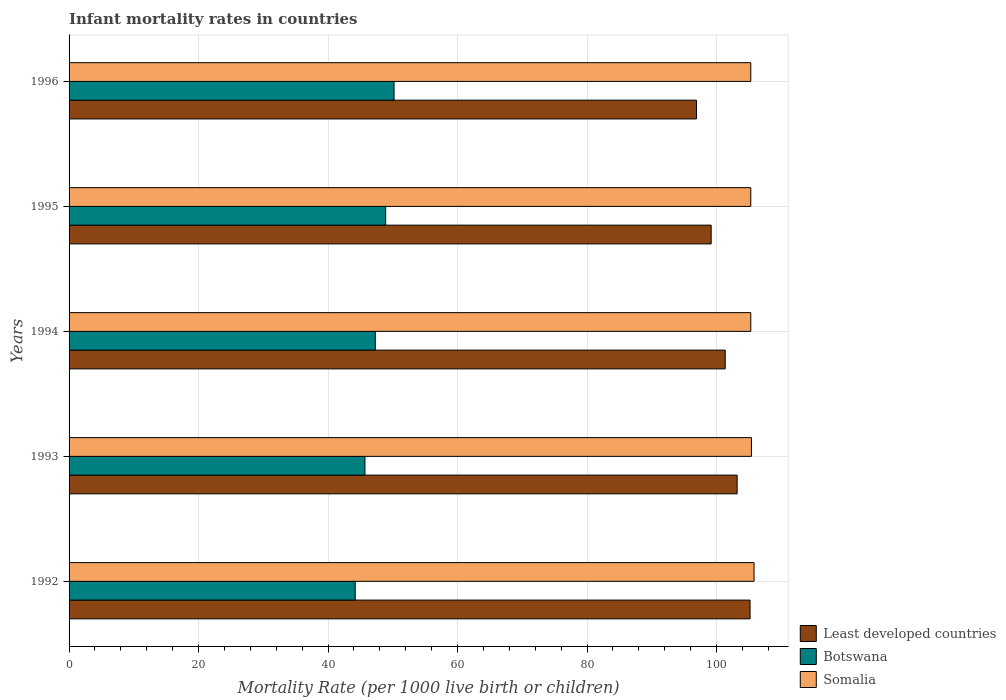How many groups of bars are there?
Provide a succinct answer. 5. Are the number of bars on each tick of the Y-axis equal?
Ensure brevity in your answer.  Yes. How many bars are there on the 5th tick from the top?
Your answer should be compact. 3. How many bars are there on the 3rd tick from the bottom?
Your answer should be very brief. 3. What is the label of the 4th group of bars from the top?
Keep it short and to the point. 1993. In how many cases, is the number of bars for a given year not equal to the number of legend labels?
Provide a short and direct response. 0. What is the infant mortality rate in Botswana in 1994?
Your answer should be very brief. 47.3. Across all years, what is the maximum infant mortality rate in Least developed countries?
Keep it short and to the point. 105.19. Across all years, what is the minimum infant mortality rate in Least developed countries?
Your answer should be very brief. 96.91. What is the total infant mortality rate in Somalia in the graph?
Offer a terse response. 527.1. What is the difference between the infant mortality rate in Least developed countries in 1993 and that in 1994?
Your answer should be very brief. 1.84. What is the difference between the infant mortality rate in Somalia in 1992 and the infant mortality rate in Botswana in 1995?
Your answer should be compact. 56.9. What is the average infant mortality rate in Botswana per year?
Provide a succinct answer. 47.26. In the year 1994, what is the difference between the infant mortality rate in Least developed countries and infant mortality rate in Botswana?
Keep it short and to the point. 54.05. What is the ratio of the infant mortality rate in Botswana in 1992 to that in 1996?
Your answer should be compact. 0.88. What is the difference between the highest and the second highest infant mortality rate in Least developed countries?
Your response must be concise. 1.99. In how many years, is the infant mortality rate in Somalia greater than the average infant mortality rate in Somalia taken over all years?
Your answer should be very brief. 1. What does the 1st bar from the top in 1994 represents?
Make the answer very short. Somalia. What does the 3rd bar from the bottom in 1996 represents?
Make the answer very short. Somalia. Is it the case that in every year, the sum of the infant mortality rate in Botswana and infant mortality rate in Least developed countries is greater than the infant mortality rate in Somalia?
Your answer should be compact. Yes. How many bars are there?
Give a very brief answer. 15. How many years are there in the graph?
Offer a terse response. 5. Are the values on the major ticks of X-axis written in scientific E-notation?
Your response must be concise. No. Does the graph contain grids?
Your answer should be compact. Yes. Where does the legend appear in the graph?
Offer a terse response. Bottom right. What is the title of the graph?
Give a very brief answer. Infant mortality rates in countries. Does "Palau" appear as one of the legend labels in the graph?
Offer a very short reply. No. What is the label or title of the X-axis?
Offer a very short reply. Mortality Rate (per 1000 live birth or children). What is the label or title of the Y-axis?
Offer a terse response. Years. What is the Mortality Rate (per 1000 live birth or children) of Least developed countries in 1992?
Make the answer very short. 105.19. What is the Mortality Rate (per 1000 live birth or children) in Botswana in 1992?
Provide a short and direct response. 44.2. What is the Mortality Rate (per 1000 live birth or children) in Somalia in 1992?
Provide a short and direct response. 105.8. What is the Mortality Rate (per 1000 live birth or children) of Least developed countries in 1993?
Provide a short and direct response. 103.19. What is the Mortality Rate (per 1000 live birth or children) in Botswana in 1993?
Provide a short and direct response. 45.7. What is the Mortality Rate (per 1000 live birth or children) in Somalia in 1993?
Provide a short and direct response. 105.4. What is the Mortality Rate (per 1000 live birth or children) of Least developed countries in 1994?
Your response must be concise. 101.35. What is the Mortality Rate (per 1000 live birth or children) of Botswana in 1994?
Provide a short and direct response. 47.3. What is the Mortality Rate (per 1000 live birth or children) in Somalia in 1994?
Your answer should be very brief. 105.3. What is the Mortality Rate (per 1000 live birth or children) of Least developed countries in 1995?
Provide a succinct answer. 99.18. What is the Mortality Rate (per 1000 live birth or children) in Botswana in 1995?
Offer a terse response. 48.9. What is the Mortality Rate (per 1000 live birth or children) in Somalia in 1995?
Make the answer very short. 105.3. What is the Mortality Rate (per 1000 live birth or children) of Least developed countries in 1996?
Offer a very short reply. 96.91. What is the Mortality Rate (per 1000 live birth or children) in Botswana in 1996?
Make the answer very short. 50.2. What is the Mortality Rate (per 1000 live birth or children) of Somalia in 1996?
Your answer should be very brief. 105.3. Across all years, what is the maximum Mortality Rate (per 1000 live birth or children) of Least developed countries?
Keep it short and to the point. 105.19. Across all years, what is the maximum Mortality Rate (per 1000 live birth or children) in Botswana?
Make the answer very short. 50.2. Across all years, what is the maximum Mortality Rate (per 1000 live birth or children) of Somalia?
Provide a short and direct response. 105.8. Across all years, what is the minimum Mortality Rate (per 1000 live birth or children) in Least developed countries?
Provide a succinct answer. 96.91. Across all years, what is the minimum Mortality Rate (per 1000 live birth or children) of Botswana?
Your answer should be compact. 44.2. Across all years, what is the minimum Mortality Rate (per 1000 live birth or children) in Somalia?
Provide a succinct answer. 105.3. What is the total Mortality Rate (per 1000 live birth or children) of Least developed countries in the graph?
Your answer should be compact. 505.82. What is the total Mortality Rate (per 1000 live birth or children) in Botswana in the graph?
Offer a terse response. 236.3. What is the total Mortality Rate (per 1000 live birth or children) in Somalia in the graph?
Keep it short and to the point. 527.1. What is the difference between the Mortality Rate (per 1000 live birth or children) of Least developed countries in 1992 and that in 1993?
Give a very brief answer. 1.99. What is the difference between the Mortality Rate (per 1000 live birth or children) of Botswana in 1992 and that in 1993?
Your answer should be compact. -1.5. What is the difference between the Mortality Rate (per 1000 live birth or children) of Least developed countries in 1992 and that in 1994?
Keep it short and to the point. 3.84. What is the difference between the Mortality Rate (per 1000 live birth or children) of Botswana in 1992 and that in 1994?
Provide a succinct answer. -3.1. What is the difference between the Mortality Rate (per 1000 live birth or children) in Least developed countries in 1992 and that in 1995?
Your answer should be very brief. 6.01. What is the difference between the Mortality Rate (per 1000 live birth or children) of Somalia in 1992 and that in 1995?
Your answer should be compact. 0.5. What is the difference between the Mortality Rate (per 1000 live birth or children) in Least developed countries in 1992 and that in 1996?
Offer a very short reply. 8.27. What is the difference between the Mortality Rate (per 1000 live birth or children) in Botswana in 1992 and that in 1996?
Give a very brief answer. -6. What is the difference between the Mortality Rate (per 1000 live birth or children) in Somalia in 1992 and that in 1996?
Offer a terse response. 0.5. What is the difference between the Mortality Rate (per 1000 live birth or children) of Least developed countries in 1993 and that in 1994?
Offer a very short reply. 1.84. What is the difference between the Mortality Rate (per 1000 live birth or children) of Botswana in 1993 and that in 1994?
Your response must be concise. -1.6. What is the difference between the Mortality Rate (per 1000 live birth or children) in Least developed countries in 1993 and that in 1995?
Your response must be concise. 4.01. What is the difference between the Mortality Rate (per 1000 live birth or children) in Least developed countries in 1993 and that in 1996?
Offer a terse response. 6.28. What is the difference between the Mortality Rate (per 1000 live birth or children) in Somalia in 1993 and that in 1996?
Offer a very short reply. 0.1. What is the difference between the Mortality Rate (per 1000 live birth or children) in Least developed countries in 1994 and that in 1995?
Your answer should be compact. 2.17. What is the difference between the Mortality Rate (per 1000 live birth or children) of Botswana in 1994 and that in 1995?
Ensure brevity in your answer.  -1.6. What is the difference between the Mortality Rate (per 1000 live birth or children) of Least developed countries in 1994 and that in 1996?
Give a very brief answer. 4.44. What is the difference between the Mortality Rate (per 1000 live birth or children) of Botswana in 1994 and that in 1996?
Give a very brief answer. -2.9. What is the difference between the Mortality Rate (per 1000 live birth or children) in Somalia in 1994 and that in 1996?
Offer a terse response. 0. What is the difference between the Mortality Rate (per 1000 live birth or children) in Least developed countries in 1995 and that in 1996?
Keep it short and to the point. 2.27. What is the difference between the Mortality Rate (per 1000 live birth or children) of Somalia in 1995 and that in 1996?
Your answer should be very brief. 0. What is the difference between the Mortality Rate (per 1000 live birth or children) of Least developed countries in 1992 and the Mortality Rate (per 1000 live birth or children) of Botswana in 1993?
Offer a very short reply. 59.49. What is the difference between the Mortality Rate (per 1000 live birth or children) of Least developed countries in 1992 and the Mortality Rate (per 1000 live birth or children) of Somalia in 1993?
Your answer should be very brief. -0.21. What is the difference between the Mortality Rate (per 1000 live birth or children) in Botswana in 1992 and the Mortality Rate (per 1000 live birth or children) in Somalia in 1993?
Provide a succinct answer. -61.2. What is the difference between the Mortality Rate (per 1000 live birth or children) of Least developed countries in 1992 and the Mortality Rate (per 1000 live birth or children) of Botswana in 1994?
Provide a succinct answer. 57.89. What is the difference between the Mortality Rate (per 1000 live birth or children) of Least developed countries in 1992 and the Mortality Rate (per 1000 live birth or children) of Somalia in 1994?
Offer a very short reply. -0.11. What is the difference between the Mortality Rate (per 1000 live birth or children) in Botswana in 1992 and the Mortality Rate (per 1000 live birth or children) in Somalia in 1994?
Your answer should be compact. -61.1. What is the difference between the Mortality Rate (per 1000 live birth or children) of Least developed countries in 1992 and the Mortality Rate (per 1000 live birth or children) of Botswana in 1995?
Make the answer very short. 56.29. What is the difference between the Mortality Rate (per 1000 live birth or children) in Least developed countries in 1992 and the Mortality Rate (per 1000 live birth or children) in Somalia in 1995?
Your response must be concise. -0.11. What is the difference between the Mortality Rate (per 1000 live birth or children) of Botswana in 1992 and the Mortality Rate (per 1000 live birth or children) of Somalia in 1995?
Provide a short and direct response. -61.1. What is the difference between the Mortality Rate (per 1000 live birth or children) in Least developed countries in 1992 and the Mortality Rate (per 1000 live birth or children) in Botswana in 1996?
Offer a terse response. 54.99. What is the difference between the Mortality Rate (per 1000 live birth or children) of Least developed countries in 1992 and the Mortality Rate (per 1000 live birth or children) of Somalia in 1996?
Give a very brief answer. -0.11. What is the difference between the Mortality Rate (per 1000 live birth or children) in Botswana in 1992 and the Mortality Rate (per 1000 live birth or children) in Somalia in 1996?
Offer a terse response. -61.1. What is the difference between the Mortality Rate (per 1000 live birth or children) of Least developed countries in 1993 and the Mortality Rate (per 1000 live birth or children) of Botswana in 1994?
Provide a succinct answer. 55.89. What is the difference between the Mortality Rate (per 1000 live birth or children) in Least developed countries in 1993 and the Mortality Rate (per 1000 live birth or children) in Somalia in 1994?
Your answer should be very brief. -2.11. What is the difference between the Mortality Rate (per 1000 live birth or children) in Botswana in 1993 and the Mortality Rate (per 1000 live birth or children) in Somalia in 1994?
Your answer should be compact. -59.6. What is the difference between the Mortality Rate (per 1000 live birth or children) in Least developed countries in 1993 and the Mortality Rate (per 1000 live birth or children) in Botswana in 1995?
Make the answer very short. 54.29. What is the difference between the Mortality Rate (per 1000 live birth or children) of Least developed countries in 1993 and the Mortality Rate (per 1000 live birth or children) of Somalia in 1995?
Give a very brief answer. -2.11. What is the difference between the Mortality Rate (per 1000 live birth or children) in Botswana in 1993 and the Mortality Rate (per 1000 live birth or children) in Somalia in 1995?
Your response must be concise. -59.6. What is the difference between the Mortality Rate (per 1000 live birth or children) in Least developed countries in 1993 and the Mortality Rate (per 1000 live birth or children) in Botswana in 1996?
Your answer should be compact. 52.99. What is the difference between the Mortality Rate (per 1000 live birth or children) in Least developed countries in 1993 and the Mortality Rate (per 1000 live birth or children) in Somalia in 1996?
Offer a very short reply. -2.11. What is the difference between the Mortality Rate (per 1000 live birth or children) in Botswana in 1993 and the Mortality Rate (per 1000 live birth or children) in Somalia in 1996?
Your response must be concise. -59.6. What is the difference between the Mortality Rate (per 1000 live birth or children) of Least developed countries in 1994 and the Mortality Rate (per 1000 live birth or children) of Botswana in 1995?
Make the answer very short. 52.45. What is the difference between the Mortality Rate (per 1000 live birth or children) of Least developed countries in 1994 and the Mortality Rate (per 1000 live birth or children) of Somalia in 1995?
Keep it short and to the point. -3.95. What is the difference between the Mortality Rate (per 1000 live birth or children) of Botswana in 1994 and the Mortality Rate (per 1000 live birth or children) of Somalia in 1995?
Provide a succinct answer. -58. What is the difference between the Mortality Rate (per 1000 live birth or children) in Least developed countries in 1994 and the Mortality Rate (per 1000 live birth or children) in Botswana in 1996?
Ensure brevity in your answer.  51.15. What is the difference between the Mortality Rate (per 1000 live birth or children) of Least developed countries in 1994 and the Mortality Rate (per 1000 live birth or children) of Somalia in 1996?
Your response must be concise. -3.95. What is the difference between the Mortality Rate (per 1000 live birth or children) of Botswana in 1994 and the Mortality Rate (per 1000 live birth or children) of Somalia in 1996?
Make the answer very short. -58. What is the difference between the Mortality Rate (per 1000 live birth or children) of Least developed countries in 1995 and the Mortality Rate (per 1000 live birth or children) of Botswana in 1996?
Provide a short and direct response. 48.98. What is the difference between the Mortality Rate (per 1000 live birth or children) of Least developed countries in 1995 and the Mortality Rate (per 1000 live birth or children) of Somalia in 1996?
Your answer should be very brief. -6.12. What is the difference between the Mortality Rate (per 1000 live birth or children) of Botswana in 1995 and the Mortality Rate (per 1000 live birth or children) of Somalia in 1996?
Make the answer very short. -56.4. What is the average Mortality Rate (per 1000 live birth or children) of Least developed countries per year?
Offer a terse response. 101.16. What is the average Mortality Rate (per 1000 live birth or children) of Botswana per year?
Provide a succinct answer. 47.26. What is the average Mortality Rate (per 1000 live birth or children) of Somalia per year?
Ensure brevity in your answer.  105.42. In the year 1992, what is the difference between the Mortality Rate (per 1000 live birth or children) in Least developed countries and Mortality Rate (per 1000 live birth or children) in Botswana?
Your answer should be very brief. 60.99. In the year 1992, what is the difference between the Mortality Rate (per 1000 live birth or children) of Least developed countries and Mortality Rate (per 1000 live birth or children) of Somalia?
Your answer should be very brief. -0.61. In the year 1992, what is the difference between the Mortality Rate (per 1000 live birth or children) of Botswana and Mortality Rate (per 1000 live birth or children) of Somalia?
Your response must be concise. -61.6. In the year 1993, what is the difference between the Mortality Rate (per 1000 live birth or children) of Least developed countries and Mortality Rate (per 1000 live birth or children) of Botswana?
Offer a very short reply. 57.49. In the year 1993, what is the difference between the Mortality Rate (per 1000 live birth or children) of Least developed countries and Mortality Rate (per 1000 live birth or children) of Somalia?
Offer a terse response. -2.21. In the year 1993, what is the difference between the Mortality Rate (per 1000 live birth or children) in Botswana and Mortality Rate (per 1000 live birth or children) in Somalia?
Make the answer very short. -59.7. In the year 1994, what is the difference between the Mortality Rate (per 1000 live birth or children) of Least developed countries and Mortality Rate (per 1000 live birth or children) of Botswana?
Offer a terse response. 54.05. In the year 1994, what is the difference between the Mortality Rate (per 1000 live birth or children) in Least developed countries and Mortality Rate (per 1000 live birth or children) in Somalia?
Keep it short and to the point. -3.95. In the year 1994, what is the difference between the Mortality Rate (per 1000 live birth or children) in Botswana and Mortality Rate (per 1000 live birth or children) in Somalia?
Make the answer very short. -58. In the year 1995, what is the difference between the Mortality Rate (per 1000 live birth or children) in Least developed countries and Mortality Rate (per 1000 live birth or children) in Botswana?
Offer a terse response. 50.28. In the year 1995, what is the difference between the Mortality Rate (per 1000 live birth or children) in Least developed countries and Mortality Rate (per 1000 live birth or children) in Somalia?
Make the answer very short. -6.12. In the year 1995, what is the difference between the Mortality Rate (per 1000 live birth or children) in Botswana and Mortality Rate (per 1000 live birth or children) in Somalia?
Provide a succinct answer. -56.4. In the year 1996, what is the difference between the Mortality Rate (per 1000 live birth or children) in Least developed countries and Mortality Rate (per 1000 live birth or children) in Botswana?
Offer a very short reply. 46.71. In the year 1996, what is the difference between the Mortality Rate (per 1000 live birth or children) in Least developed countries and Mortality Rate (per 1000 live birth or children) in Somalia?
Offer a very short reply. -8.39. In the year 1996, what is the difference between the Mortality Rate (per 1000 live birth or children) in Botswana and Mortality Rate (per 1000 live birth or children) in Somalia?
Your answer should be compact. -55.1. What is the ratio of the Mortality Rate (per 1000 live birth or children) in Least developed countries in 1992 to that in 1993?
Your answer should be very brief. 1.02. What is the ratio of the Mortality Rate (per 1000 live birth or children) of Botswana in 1992 to that in 1993?
Your answer should be very brief. 0.97. What is the ratio of the Mortality Rate (per 1000 live birth or children) of Somalia in 1992 to that in 1993?
Provide a succinct answer. 1. What is the ratio of the Mortality Rate (per 1000 live birth or children) of Least developed countries in 1992 to that in 1994?
Offer a terse response. 1.04. What is the ratio of the Mortality Rate (per 1000 live birth or children) in Botswana in 1992 to that in 1994?
Make the answer very short. 0.93. What is the ratio of the Mortality Rate (per 1000 live birth or children) in Somalia in 1992 to that in 1994?
Ensure brevity in your answer.  1. What is the ratio of the Mortality Rate (per 1000 live birth or children) of Least developed countries in 1992 to that in 1995?
Give a very brief answer. 1.06. What is the ratio of the Mortality Rate (per 1000 live birth or children) in Botswana in 1992 to that in 1995?
Offer a very short reply. 0.9. What is the ratio of the Mortality Rate (per 1000 live birth or children) in Somalia in 1992 to that in 1995?
Your answer should be very brief. 1. What is the ratio of the Mortality Rate (per 1000 live birth or children) in Least developed countries in 1992 to that in 1996?
Offer a very short reply. 1.09. What is the ratio of the Mortality Rate (per 1000 live birth or children) in Botswana in 1992 to that in 1996?
Your response must be concise. 0.88. What is the ratio of the Mortality Rate (per 1000 live birth or children) of Somalia in 1992 to that in 1996?
Offer a very short reply. 1. What is the ratio of the Mortality Rate (per 1000 live birth or children) in Least developed countries in 1993 to that in 1994?
Make the answer very short. 1.02. What is the ratio of the Mortality Rate (per 1000 live birth or children) of Botswana in 1993 to that in 1994?
Offer a very short reply. 0.97. What is the ratio of the Mortality Rate (per 1000 live birth or children) of Somalia in 1993 to that in 1994?
Offer a terse response. 1. What is the ratio of the Mortality Rate (per 1000 live birth or children) of Least developed countries in 1993 to that in 1995?
Ensure brevity in your answer.  1.04. What is the ratio of the Mortality Rate (per 1000 live birth or children) in Botswana in 1993 to that in 1995?
Your answer should be compact. 0.93. What is the ratio of the Mortality Rate (per 1000 live birth or children) in Least developed countries in 1993 to that in 1996?
Your answer should be very brief. 1.06. What is the ratio of the Mortality Rate (per 1000 live birth or children) in Botswana in 1993 to that in 1996?
Provide a short and direct response. 0.91. What is the ratio of the Mortality Rate (per 1000 live birth or children) in Somalia in 1993 to that in 1996?
Provide a short and direct response. 1. What is the ratio of the Mortality Rate (per 1000 live birth or children) of Least developed countries in 1994 to that in 1995?
Offer a very short reply. 1.02. What is the ratio of the Mortality Rate (per 1000 live birth or children) in Botswana in 1994 to that in 1995?
Give a very brief answer. 0.97. What is the ratio of the Mortality Rate (per 1000 live birth or children) of Somalia in 1994 to that in 1995?
Provide a succinct answer. 1. What is the ratio of the Mortality Rate (per 1000 live birth or children) of Least developed countries in 1994 to that in 1996?
Your response must be concise. 1.05. What is the ratio of the Mortality Rate (per 1000 live birth or children) in Botswana in 1994 to that in 1996?
Your response must be concise. 0.94. What is the ratio of the Mortality Rate (per 1000 live birth or children) of Least developed countries in 1995 to that in 1996?
Your answer should be compact. 1.02. What is the ratio of the Mortality Rate (per 1000 live birth or children) in Botswana in 1995 to that in 1996?
Provide a succinct answer. 0.97. What is the ratio of the Mortality Rate (per 1000 live birth or children) of Somalia in 1995 to that in 1996?
Make the answer very short. 1. What is the difference between the highest and the second highest Mortality Rate (per 1000 live birth or children) in Least developed countries?
Give a very brief answer. 1.99. What is the difference between the highest and the lowest Mortality Rate (per 1000 live birth or children) in Least developed countries?
Make the answer very short. 8.27. What is the difference between the highest and the lowest Mortality Rate (per 1000 live birth or children) in Botswana?
Make the answer very short. 6. What is the difference between the highest and the lowest Mortality Rate (per 1000 live birth or children) of Somalia?
Offer a terse response. 0.5. 